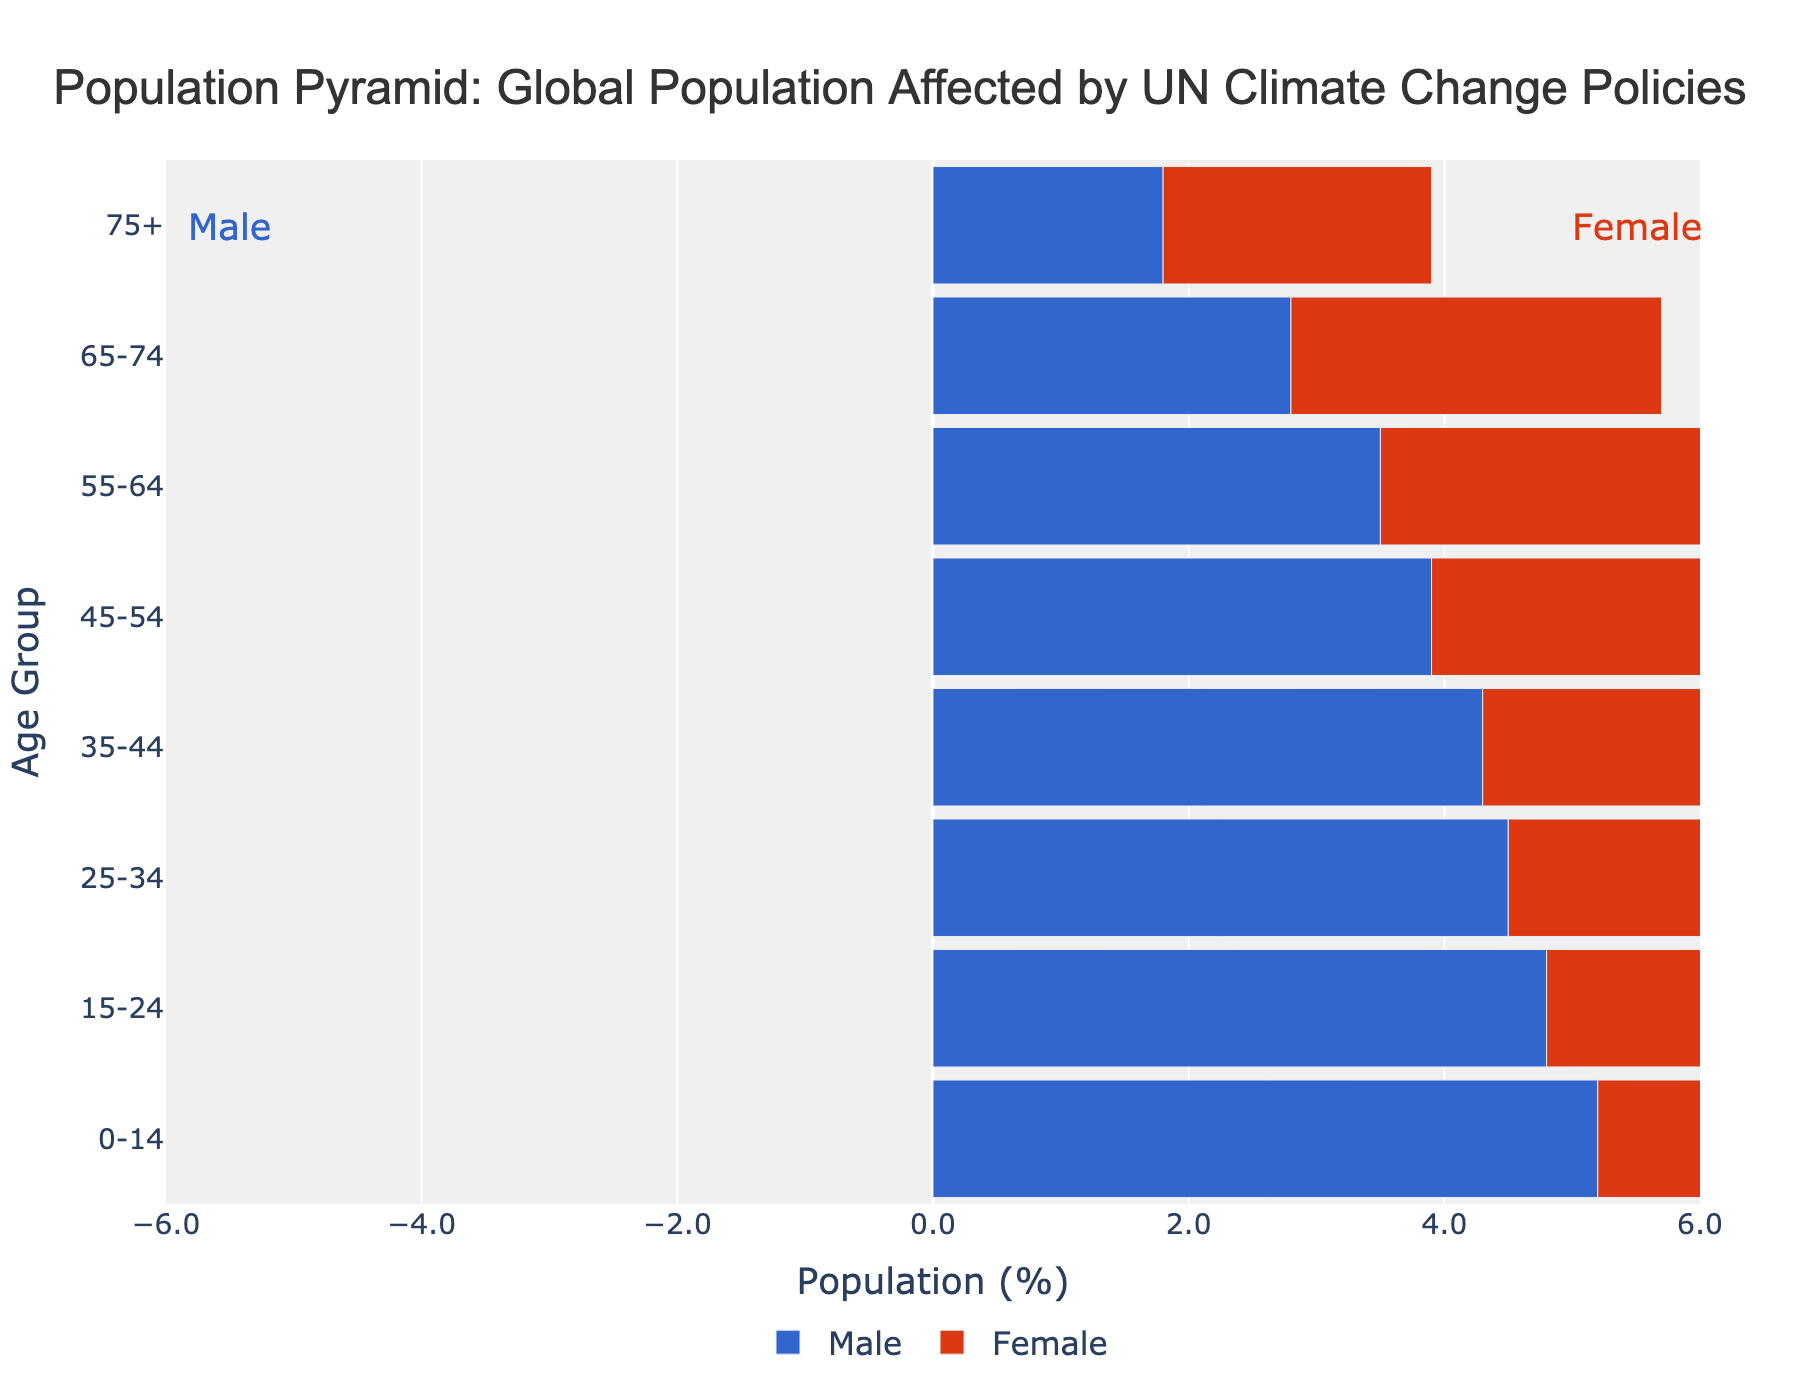What is the title of the plot? The title is centered at the top of the plot, making it easy to identify.
Answer: Population Pyramid: Global Population Affected by UN Climate Change Policies What is the age group with the highest percentage of males? The highest negative value in the male section represents the age group with the highest percentage of males.
Answer: 0-14 Which age group has more females than males? Compare the lengths of bars for males and females within each age group. An age group where the female bar exceeds the male bar indicates more females.
Answer: 65-74 and 75+ What trend is noticeable in the gender distribution as age increases? Observe the relative lengths of male and female bars from younger to older age groups; females' bars get longer while males' get shorter.
Answer: There are more females in older age groups 